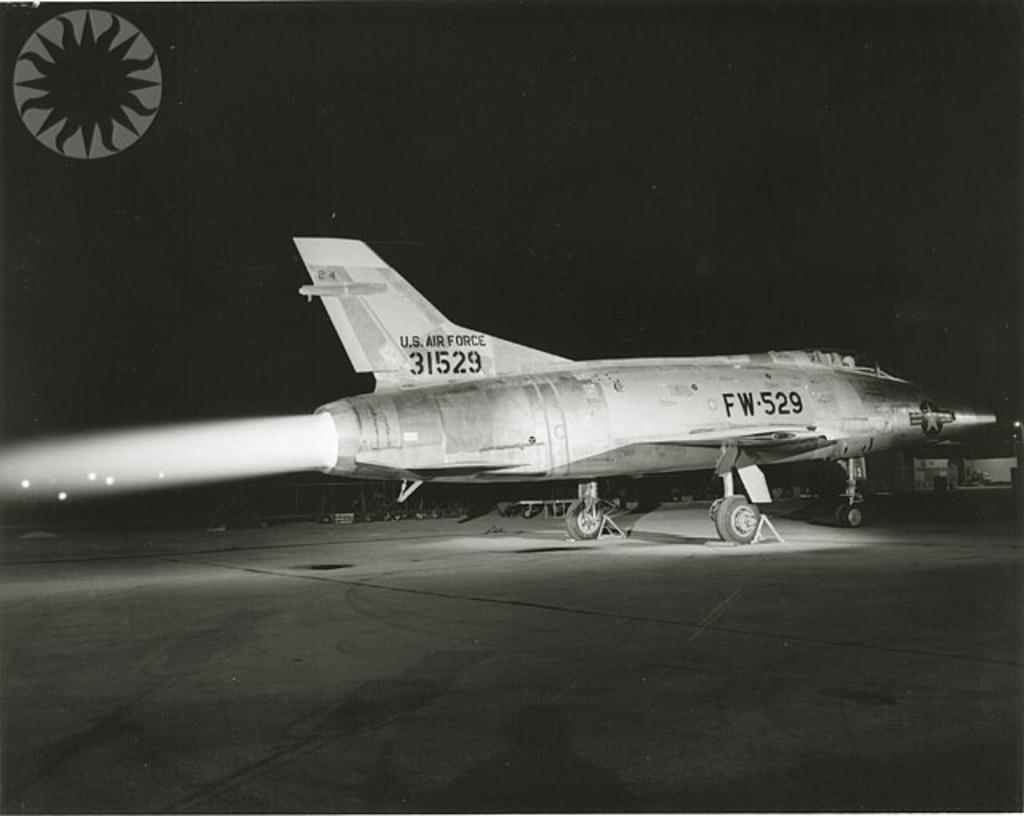<image>
Create a compact narrative representing the image presented. Airplane parked on the ground with the numbers 31529 on it's tail. 